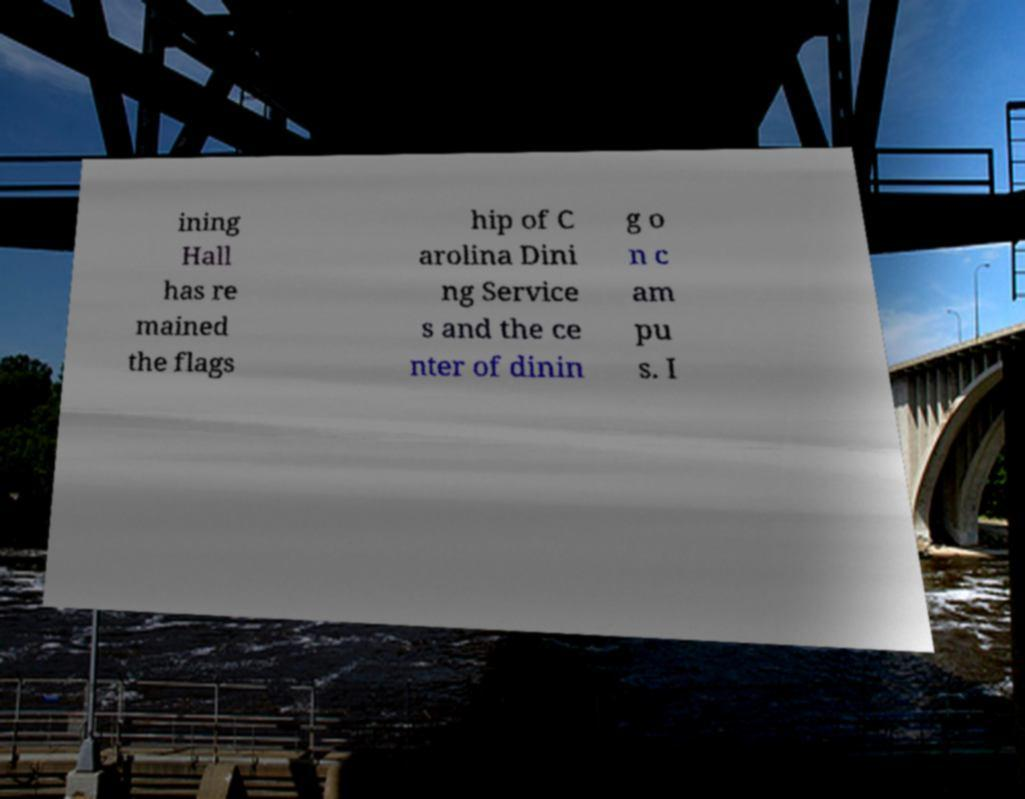There's text embedded in this image that I need extracted. Can you transcribe it verbatim? ining Hall has re mained the flags hip of C arolina Dini ng Service s and the ce nter of dinin g o n c am pu s. I 